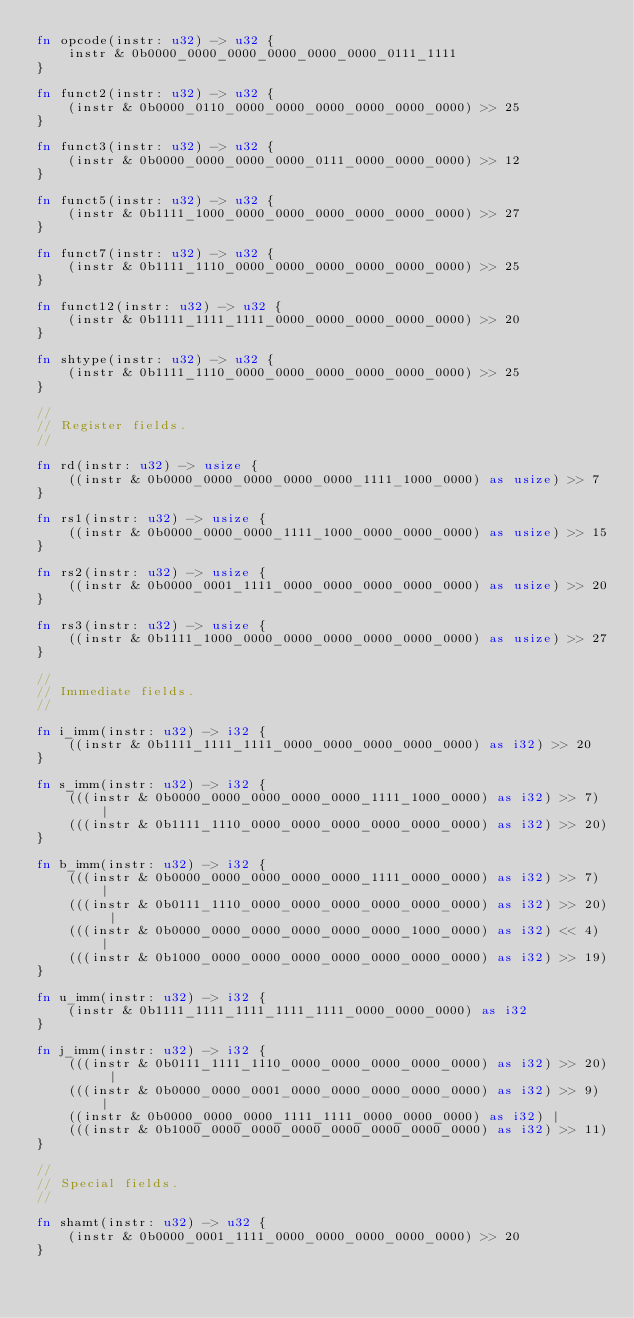Convert code to text. <code><loc_0><loc_0><loc_500><loc_500><_Rust_>fn opcode(instr: u32) -> u32 {
    instr & 0b0000_0000_0000_0000_0000_0000_0111_1111
}

fn funct2(instr: u32) -> u32 {
    (instr & 0b0000_0110_0000_0000_0000_0000_0000_0000) >> 25
}

fn funct3(instr: u32) -> u32 {
    (instr & 0b0000_0000_0000_0000_0111_0000_0000_0000) >> 12
}

fn funct5(instr: u32) -> u32 {
    (instr & 0b1111_1000_0000_0000_0000_0000_0000_0000) >> 27
}

fn funct7(instr: u32) -> u32 {
    (instr & 0b1111_1110_0000_0000_0000_0000_0000_0000) >> 25
}

fn funct12(instr: u32) -> u32 { 
    (instr & 0b1111_1111_1111_0000_0000_0000_0000_0000) >> 20
}

fn shtype(instr: u32) -> u32 {
    (instr & 0b1111_1110_0000_0000_0000_0000_0000_0000) >> 25
}

//
// Register fields.
//

fn rd(instr: u32) -> usize {
    ((instr & 0b0000_0000_0000_0000_0000_1111_1000_0000) as usize) >> 7
}

fn rs1(instr: u32) -> usize {
    ((instr & 0b0000_0000_0000_1111_1000_0000_0000_0000) as usize) >> 15
}

fn rs2(instr: u32) -> usize {
    ((instr & 0b0000_0001_1111_0000_0000_0000_0000_0000) as usize) >> 20
}

fn rs3(instr: u32) -> usize {
    ((instr & 0b1111_1000_0000_0000_0000_0000_0000_0000) as usize) >> 27
}

//
// Immediate fields.
//

fn i_imm(instr: u32) -> i32 {
    ((instr & 0b1111_1111_1111_0000_0000_0000_0000_0000) as i32) >> 20
}

fn s_imm(instr: u32) -> i32 {
    (((instr & 0b0000_0000_0000_0000_0000_1111_1000_0000) as i32) >> 7) |
    (((instr & 0b1111_1110_0000_0000_0000_0000_0000_0000) as i32) >> 20)
}

fn b_imm(instr: u32) -> i32 {
    (((instr & 0b0000_0000_0000_0000_0000_1111_0000_0000) as i32) >> 7) |
    (((instr & 0b0111_1110_0000_0000_0000_0000_0000_0000) as i32) >> 20) |
    (((instr & 0b0000_0000_0000_0000_0000_0000_1000_0000) as i32) << 4) |
    (((instr & 0b1000_0000_0000_0000_0000_0000_0000_0000) as i32) >> 19)
}

fn u_imm(instr: u32) -> i32 {
    (instr & 0b1111_1111_1111_1111_1111_0000_0000_0000) as i32
}

fn j_imm(instr: u32) -> i32 {
    (((instr & 0b0111_1111_1110_0000_0000_0000_0000_0000) as i32) >> 20) |
    (((instr & 0b0000_0000_0001_0000_0000_0000_0000_0000) as i32) >> 9) |
    ((instr & 0b0000_0000_0000_1111_1111_0000_0000_0000) as i32) |
    (((instr & 0b1000_0000_0000_0000_0000_0000_0000_0000) as i32) >> 11)
}

//
// Special fields.
//

fn shamt(instr: u32) -> u32 {
    (instr & 0b0000_0001_1111_0000_0000_0000_0000_0000) >> 20
}
</code> 